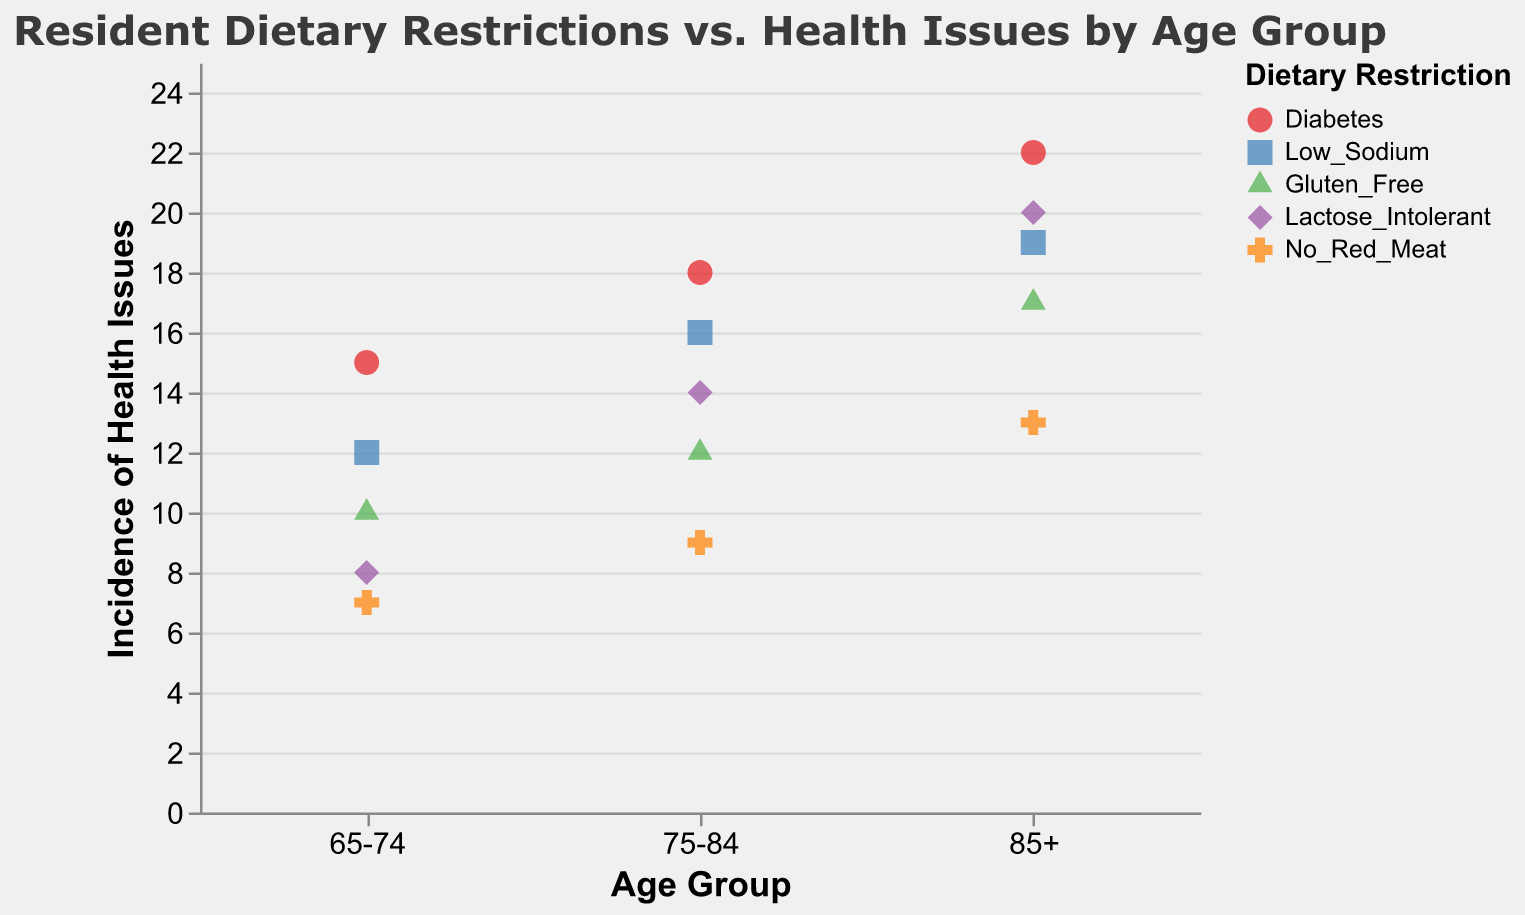What is the title of the plot? The title of the plot is usually displayed at the top of the chart. In this case, it reads "Resident Dietary Restrictions vs. Health Issues by Age Group".
Answer: Resident Dietary Restrictions vs. Health Issues by Age Group Which dietary restriction has the highest incidence of health issues in the 85+ age group? To find this, look at the data points for the 85+ age group on the x-axis and find the one with the highest y-value (Incidence of Health Issues). The highest incidence is 22, which corresponds to Diabetes, indicated by the color and shape legend.
Answer: Diabetes How many total dietary restrictions are displayed in the plot? The color and shape legend indicates five different dietary restrictions: Diabetes, Low Sodium, Gluten Free, Lactose Intolerant, and No Red Meat.
Answer: Five What is the total incidence of health issues for the 75-84 age group? Sum the individual incidences of health issues for each dietary restriction in the 75-84 age group: 18 (Diabetes) + 16 (Low Sodium) + 12 (Gluten Free) + 14 (Lactose Intolerant) + 9 (No Red Meat) = 69.
Answer: 69 Which dietary restriction has the lowest incidence of health issues across all age groups? By looking at all the plotted points on the y-axis and comparing them, the lowest incidence is 7, found in the 65-74 age group for No Red Meat.
Answer: No Red Meat Which age group has the highest average incidence of health issues? First, calculate the average incidence for each age group: 
65-74: (15+12+10+8+7)/5 = 10.4 
75-84: (18+16+12+14+9)/5 = 13.8 
85+: (22+19+17+20+13)/5 = 18.2. 
The 85+ age group has the highest average incidence.
Answer: 85+ How does the incidence of health issues for Lactose Intolerant in the 75-84 age group compare to the incidence of health issues for Gluten Free in the same age group? Look at the y-values for Lactose Intolerant (14) and Gluten Free (12) in the 75-84 age group. Lactose Intolerant has a higher incidence of health issues compared to Gluten Free.
Answer: Lactose Intolerant is higher Which dietary restriction shows a consistent increase in the incidence of health issues across all age groups? To find a consistent increase, compare each dietary restriction across the age groups: Diabetes increases from 15 (65-74), to 18 (75-84), to 22 (85+).
Answer: Diabetes What is the difference in the incidence of health issues between Low Sodium and No Red Meat in the 85+ age group? Find the y-values for Low Sodium (19) and No Red Meat (13) in the 85+ age group. The difference is calculated as 19 - 13 = 6.
Answer: 6 